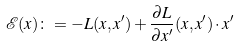Convert formula to latex. <formula><loc_0><loc_0><loc_500><loc_500>\mathcal { E } ( x ) \colon = - L ( x , x ^ { \prime } ) + \frac { \partial L } { \partial x ^ { \prime } } ( x , x ^ { \prime } ) \cdot x ^ { \prime }</formula> 